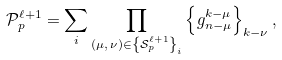<formula> <loc_0><loc_0><loc_500><loc_500>\mathcal { P } _ { p } ^ { \ell + 1 } = \sum _ { i } \prod _ { \left ( \mu , \, \nu \right ) \in \left \{ \mathcal { S } _ { p } ^ { \ell + 1 } \right \} _ { i } } \left \{ g _ { n - \mu } ^ { k - \mu } \right \} _ { k - \nu } ,</formula> 